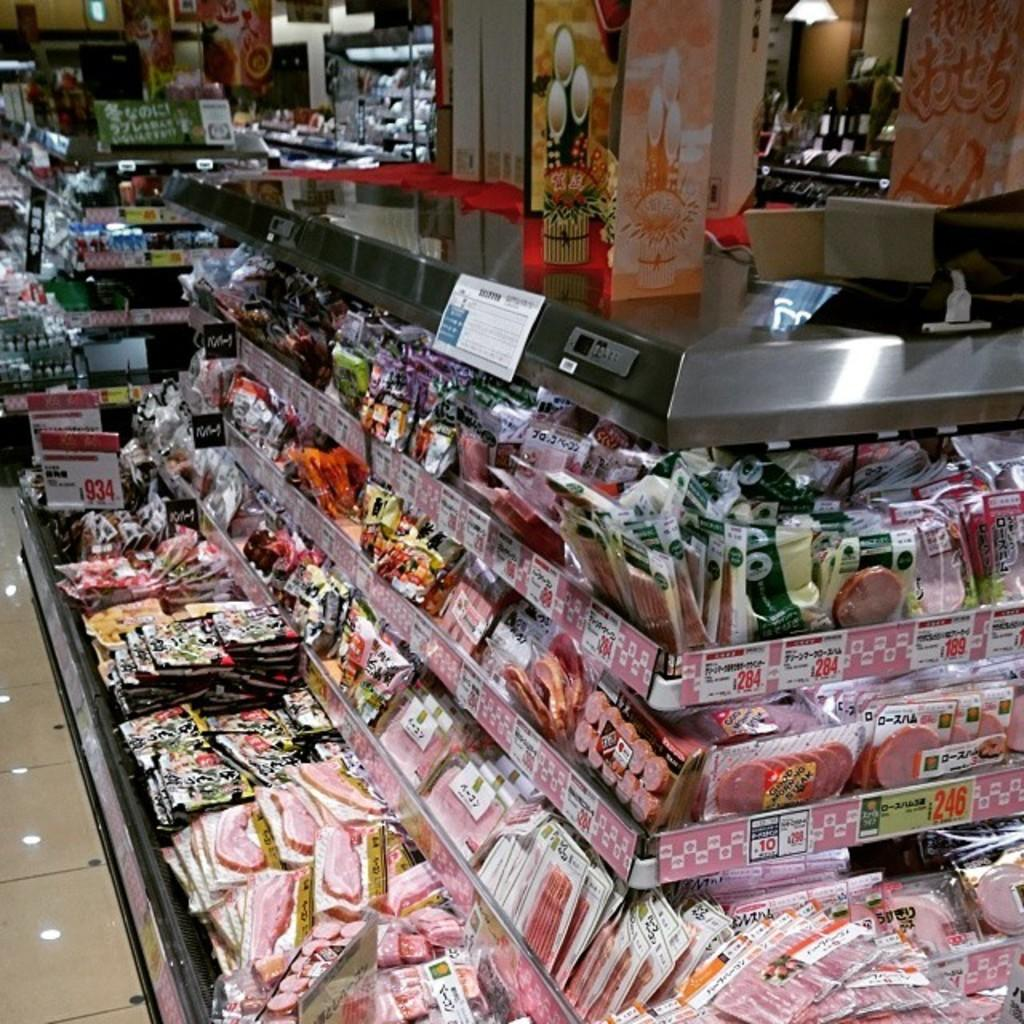What type of items can be seen in the image? There are food packets, price boards, and boxes in the image. What might be used to display pricing information? Price boards are present in the image for displaying pricing information. What other objects can be seen in the image? There are some unspecified objects in the image. Can you see any ants carrying the food packets in the image? There are no ants present in the image, and therefore no such activity can be observed. 